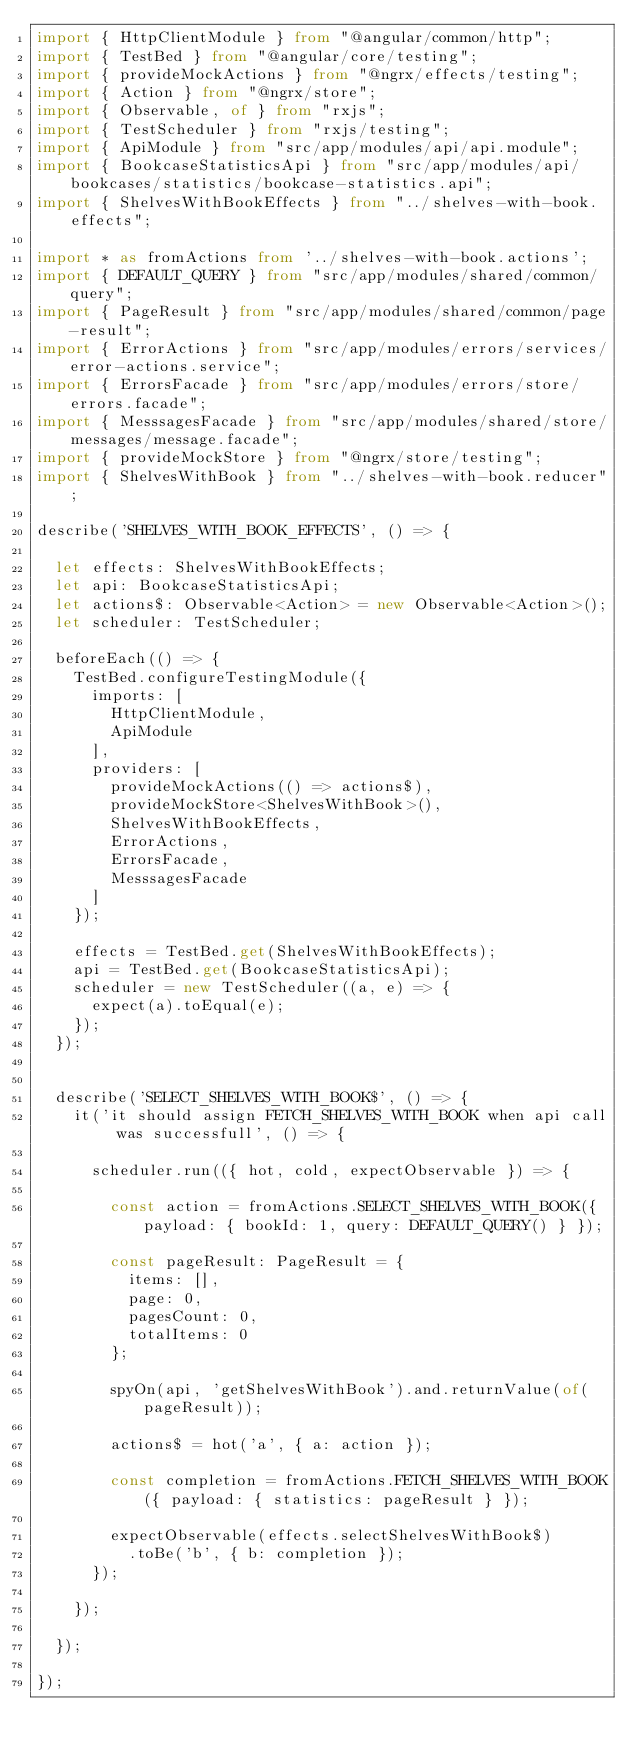<code> <loc_0><loc_0><loc_500><loc_500><_TypeScript_>import { HttpClientModule } from "@angular/common/http";
import { TestBed } from "@angular/core/testing";
import { provideMockActions } from "@ngrx/effects/testing";
import { Action } from "@ngrx/store";
import { Observable, of } from "rxjs";
import { TestScheduler } from "rxjs/testing";
import { ApiModule } from "src/app/modules/api/api.module";
import { BookcaseStatisticsApi } from "src/app/modules/api/bookcases/statistics/bookcase-statistics.api";
import { ShelvesWithBookEffects } from "../shelves-with-book.effects";

import * as fromActions from '../shelves-with-book.actions';
import { DEFAULT_QUERY } from "src/app/modules/shared/common/query";
import { PageResult } from "src/app/modules/shared/common/page-result";
import { ErrorActions } from "src/app/modules/errors/services/error-actions.service";
import { ErrorsFacade } from "src/app/modules/errors/store/errors.facade";
import { MesssagesFacade } from "src/app/modules/shared/store/messages/message.facade";
import { provideMockStore } from "@ngrx/store/testing";
import { ShelvesWithBook } from "../shelves-with-book.reducer";

describe('SHELVES_WITH_BOOK_EFFECTS', () => {

  let effects: ShelvesWithBookEffects;
  let api: BookcaseStatisticsApi;
  let actions$: Observable<Action> = new Observable<Action>();
  let scheduler: TestScheduler;

  beforeEach(() => {
    TestBed.configureTestingModule({
      imports: [
        HttpClientModule,
        ApiModule
      ],
      providers: [
        provideMockActions(() => actions$),
        provideMockStore<ShelvesWithBook>(),
        ShelvesWithBookEffects,
        ErrorActions,
        ErrorsFacade,
        MesssagesFacade
      ]
    });

    effects = TestBed.get(ShelvesWithBookEffects);
    api = TestBed.get(BookcaseStatisticsApi);
    scheduler = new TestScheduler((a, e) => {
      expect(a).toEqual(e);
    });
  });


  describe('SELECT_SHELVES_WITH_BOOK$', () => {
    it('it should assign FETCH_SHELVES_WITH_BOOK when api call was successfull', () => {

      scheduler.run(({ hot, cold, expectObservable }) => {

        const action = fromActions.SELECT_SHELVES_WITH_BOOK({ payload: { bookId: 1, query: DEFAULT_QUERY() } });

        const pageResult: PageResult = {
          items: [],
          page: 0,
          pagesCount: 0,
          totalItems: 0
        };

        spyOn(api, 'getShelvesWithBook').and.returnValue(of(pageResult));

        actions$ = hot('a', { a: action });

        const completion = fromActions.FETCH_SHELVES_WITH_BOOK({ payload: { statistics: pageResult } });

        expectObservable(effects.selectShelvesWithBook$)
          .toBe('b', { b: completion });
      });

    });

  });

});

</code> 